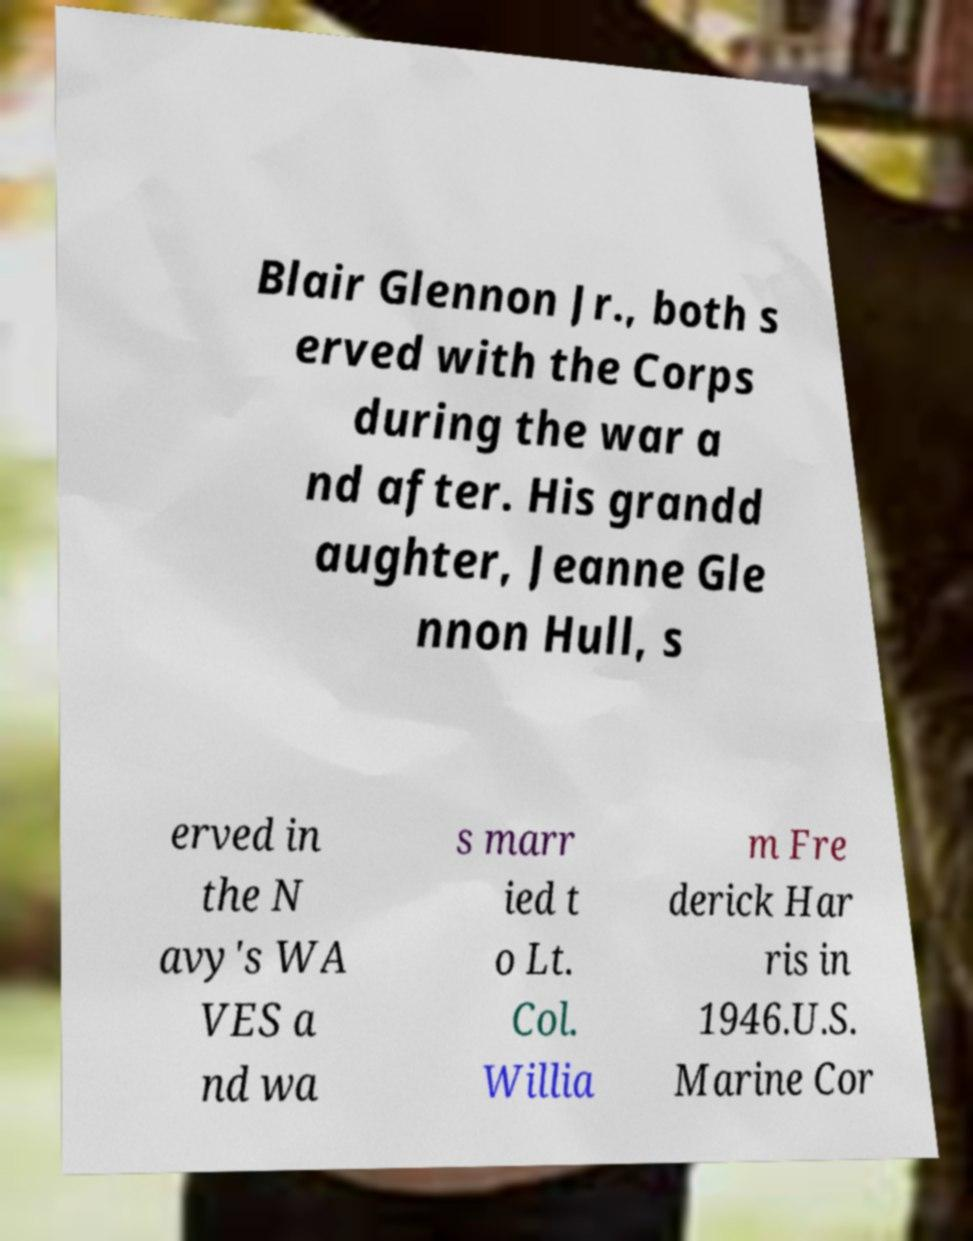What messages or text are displayed in this image? I need them in a readable, typed format. Blair Glennon Jr., both s erved with the Corps during the war a nd after. His grandd aughter, Jeanne Gle nnon Hull, s erved in the N avy's WA VES a nd wa s marr ied t o Lt. Col. Willia m Fre derick Har ris in 1946.U.S. Marine Cor 